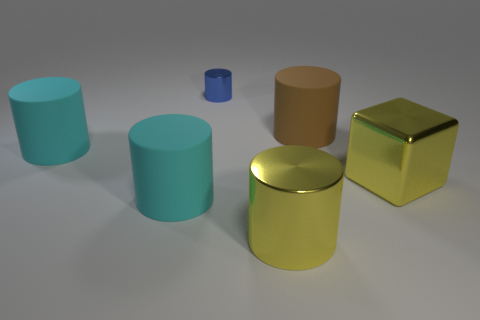Is there anything else that has the same size as the blue object?
Keep it short and to the point. No. There is a blue metal object; what number of tiny metal cylinders are on the right side of it?
Keep it short and to the point. 0. The blue object that is the same shape as the large brown object is what size?
Make the answer very short. Small. What number of purple things are either tiny objects or big cylinders?
Provide a short and direct response. 0. There is a shiny cylinder that is in front of the tiny thing; how many cyan cylinders are in front of it?
Provide a succinct answer. 0. What number of other things are the same shape as the large brown rubber object?
Ensure brevity in your answer.  4. There is a cylinder that is the same color as the metal cube; what is its material?
Your answer should be compact. Metal. How many large cylinders are the same color as the small object?
Make the answer very short. 0. What is the color of the cylinder that is the same material as the blue object?
Your answer should be compact. Yellow. Are there any yellow shiny objects that have the same size as the brown rubber object?
Your answer should be compact. Yes. 